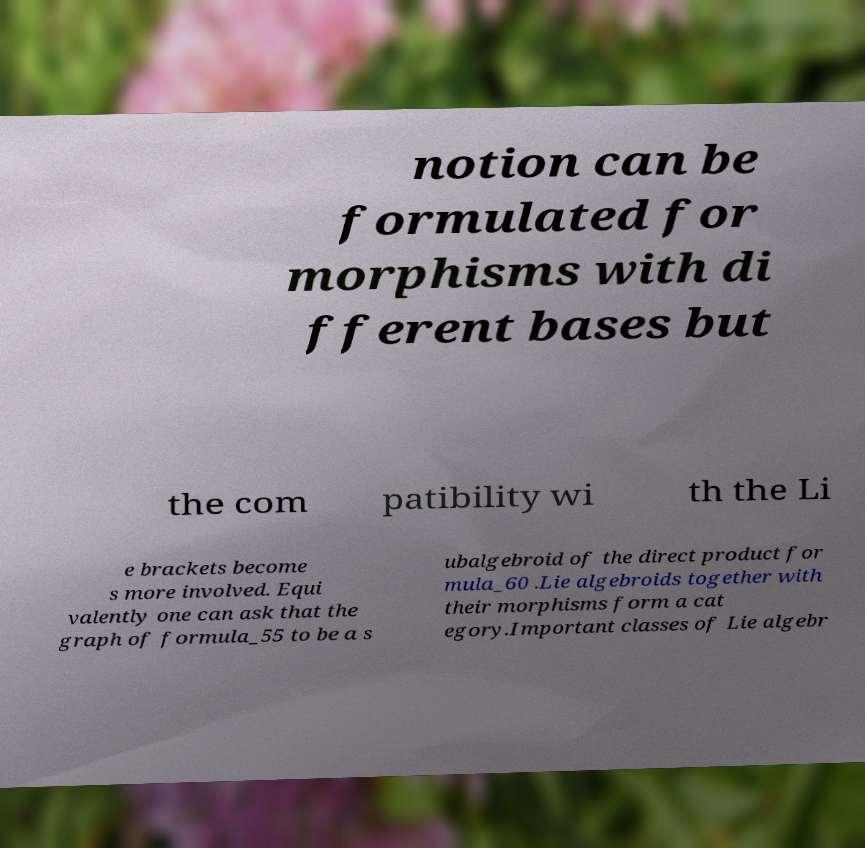What messages or text are displayed in this image? I need them in a readable, typed format. notion can be formulated for morphisms with di fferent bases but the com patibility wi th the Li e brackets become s more involved. Equi valently one can ask that the graph of formula_55 to be a s ubalgebroid of the direct product for mula_60 .Lie algebroids together with their morphisms form a cat egory.Important classes of Lie algebr 